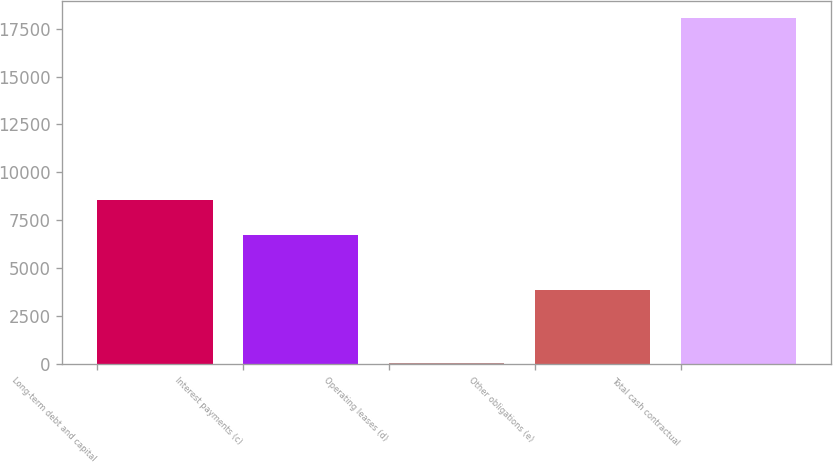Convert chart. <chart><loc_0><loc_0><loc_500><loc_500><bar_chart><fcel>Long-term debt and capital<fcel>Interest payments (c)<fcel>Operating leases (d)<fcel>Other obligations (e)<fcel>Total cash contractual<nl><fcel>8553.6<fcel>6758<fcel>81<fcel>3872<fcel>18037<nl></chart> 